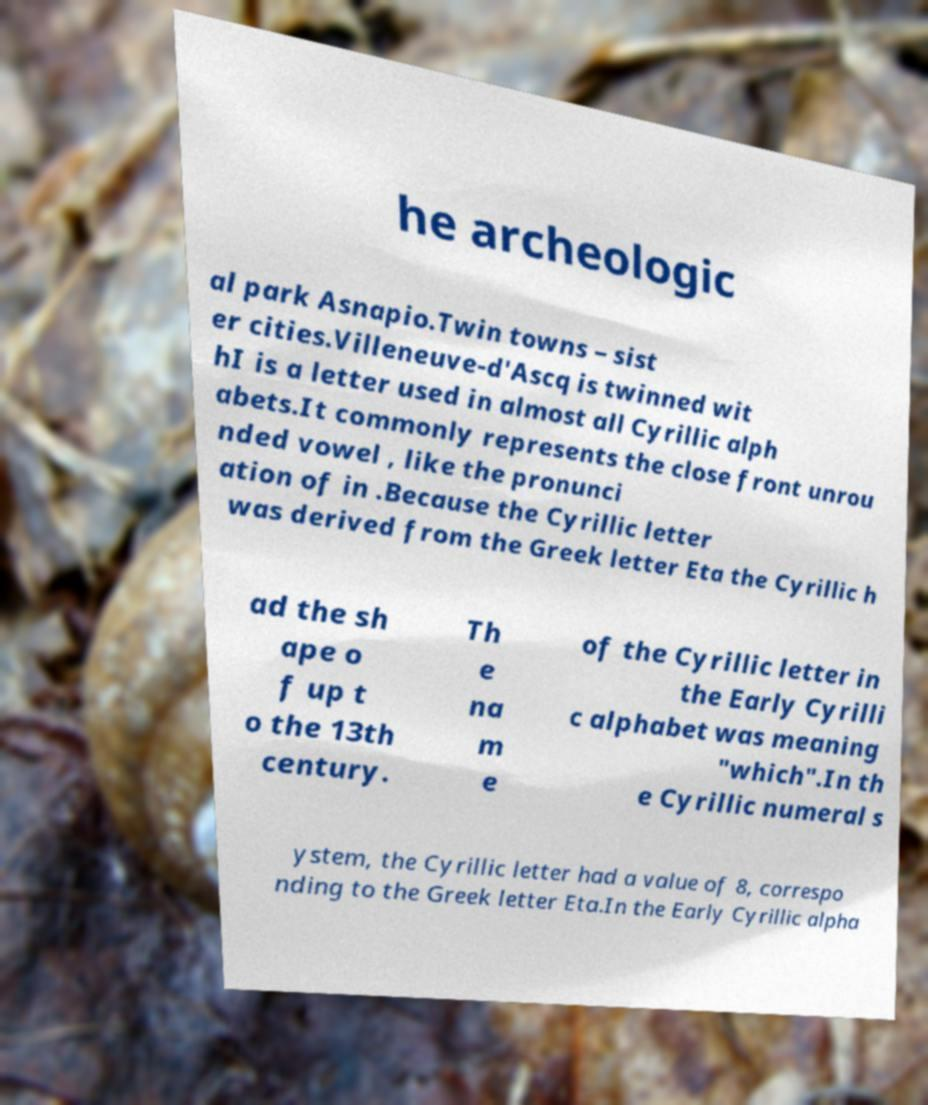There's text embedded in this image that I need extracted. Can you transcribe it verbatim? he archeologic al park Asnapio.Twin towns – sist er cities.Villeneuve-d'Ascq is twinned wit hI is a letter used in almost all Cyrillic alph abets.It commonly represents the close front unrou nded vowel , like the pronunci ation of in .Because the Cyrillic letter was derived from the Greek letter Eta the Cyrillic h ad the sh ape o f up t o the 13th century. Th e na m e of the Cyrillic letter in the Early Cyrilli c alphabet was meaning "which".In th e Cyrillic numeral s ystem, the Cyrillic letter had a value of 8, correspo nding to the Greek letter Eta.In the Early Cyrillic alpha 